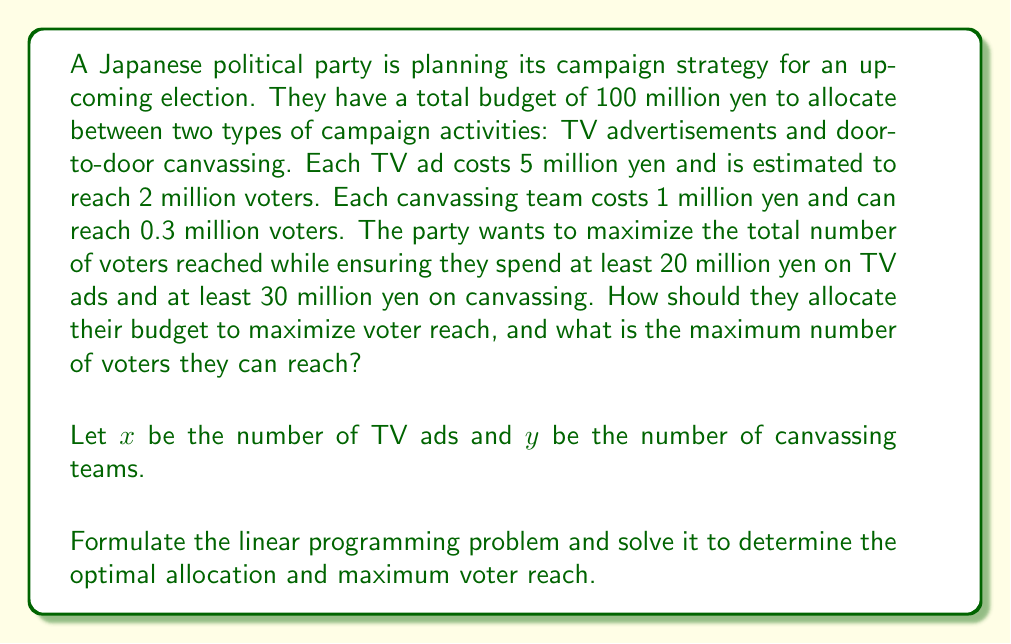Help me with this question. Let's approach this step-by-step:

1) First, we need to formulate the objective function. We want to maximize the number of voters reached:
   $$ \text{Maximize } Z = 2x + 0.3y $$
   where $Z$ is in millions of voters.

2) Now, let's identify the constraints:
   a) Budget constraint: $5x + y \leq 100$
   b) Minimum TV ad spending: $5x \geq 20$
   c) Minimum canvassing spending: $y \geq 30$
   d) Non-negativity: $x \geq 0, y \geq 0$

3) Our linear programming problem is now:
   $$ \begin{align*}
   \text{Maximize } & Z = 2x + 0.3y \\
   \text{Subject to: } & 5x + y \leq 100 \\
   & 5x \geq 20 \\
   & y \geq 30 \\
   & x, y \geq 0
   \end{align*} $$

4) To solve this, we can use the graphical method. First, let's plot the constraints:
   [asy]
   import graph;
   size(200,200);
   xaxis("x",0,20);
   yaxis("y",0,100);
   draw((4,0)--(4,80)--(16,80)--(20,0),blue);
   draw((0,30)--(20,30),red);
   label("Budget constraint",(-1,90),E);
   label("Min TV ad spending",(4,-2),N);
   label("Min canvassing",(0,28),W);
   fill((4,30)--(4,80)--(14,80)--(14,30)--cycle,paleblue);
   dot((4,80),red);
   dot((14,30),red);
   [/asy]

5) The feasible region is the shaded area. The optimal solution will be at one of the corner points. We need to evaluate Z at (4,80) and (14,30):

   At (4,80): $Z = 2(4) + 0.3(80) = 32$ million voters
   At (14,30): $Z = 2(14) + 0.3(30) = 37$ million voters

6) Therefore, the optimal solution is at (14,30), meaning 14 TV ads and 30 canvassing teams.

7) The maximum number of voters reached is 37 million.
Answer: 14 TV ads, 30 canvassing teams; 37 million voters reached 